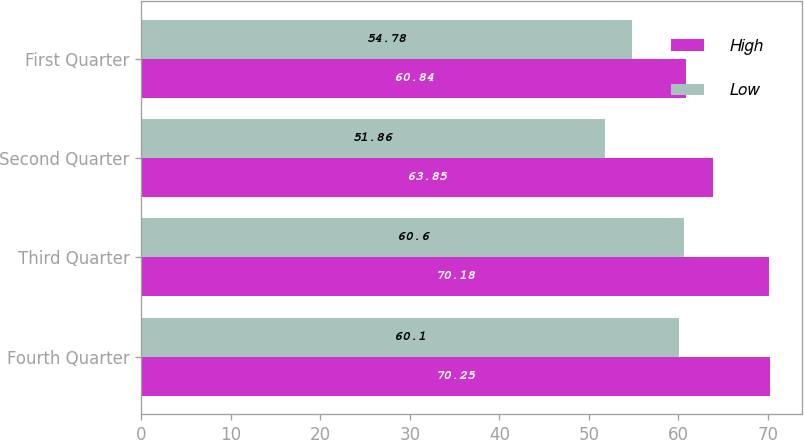Convert chart to OTSL. <chart><loc_0><loc_0><loc_500><loc_500><stacked_bar_chart><ecel><fcel>Fourth Quarter<fcel>Third Quarter<fcel>Second Quarter<fcel>First Quarter<nl><fcel>High<fcel>70.25<fcel>70.18<fcel>63.85<fcel>60.84<nl><fcel>Low<fcel>60.1<fcel>60.6<fcel>51.86<fcel>54.78<nl></chart> 